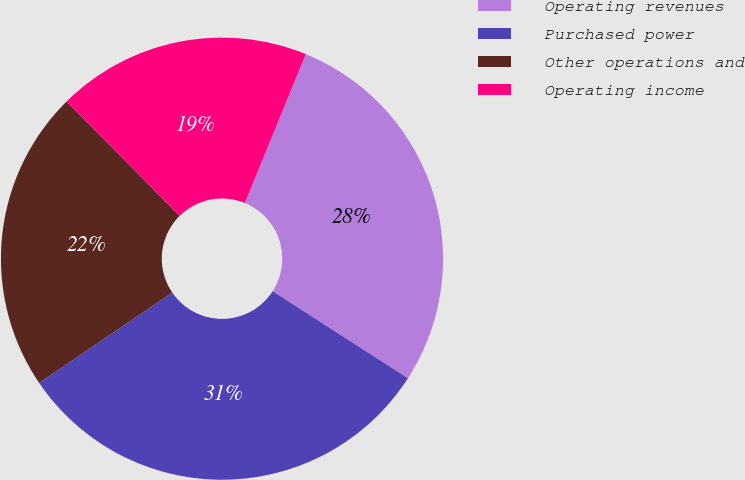Convert chart to OTSL. <chart><loc_0><loc_0><loc_500><loc_500><pie_chart><fcel>Operating revenues<fcel>Purchased power<fcel>Other operations and<fcel>Operating income<nl><fcel>27.91%<fcel>31.4%<fcel>22.09%<fcel>18.6%<nl></chart> 